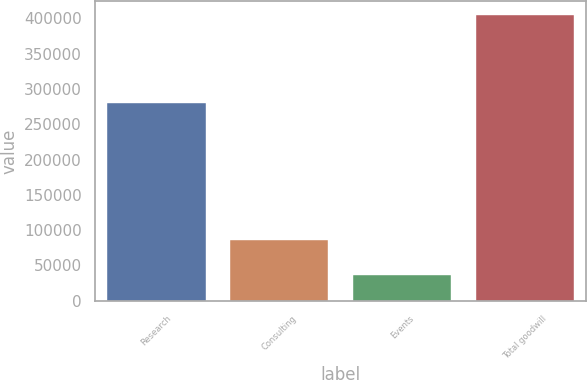Convert chart to OTSL. <chart><loc_0><loc_0><loc_500><loc_500><bar_chart><fcel>Research<fcel>Consulting<fcel>Events<fcel>Total goodwill<nl><fcel>279500<fcel>86086<fcel>36366<fcel>404034<nl></chart> 